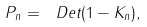Convert formula to latex. <formula><loc_0><loc_0><loc_500><loc_500>P _ { n } = \ D e t ( 1 - K _ { n } ) ,</formula> 